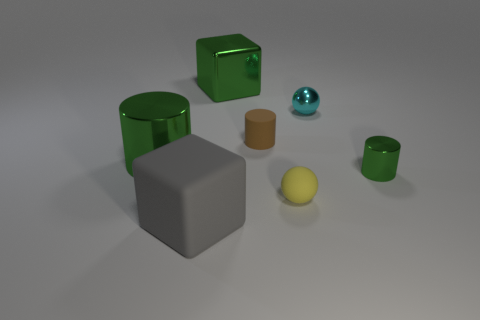Subtract all blue blocks. How many green cylinders are left? 2 Subtract all shiny cylinders. How many cylinders are left? 1 Add 1 small brown rubber cylinders. How many objects exist? 8 Subtract all spheres. How many objects are left? 5 Subtract 0 gray cylinders. How many objects are left? 7 Subtract all big yellow shiny blocks. Subtract all tiny brown rubber objects. How many objects are left? 6 Add 6 metal balls. How many metal balls are left? 7 Add 2 small cyan balls. How many small cyan balls exist? 3 